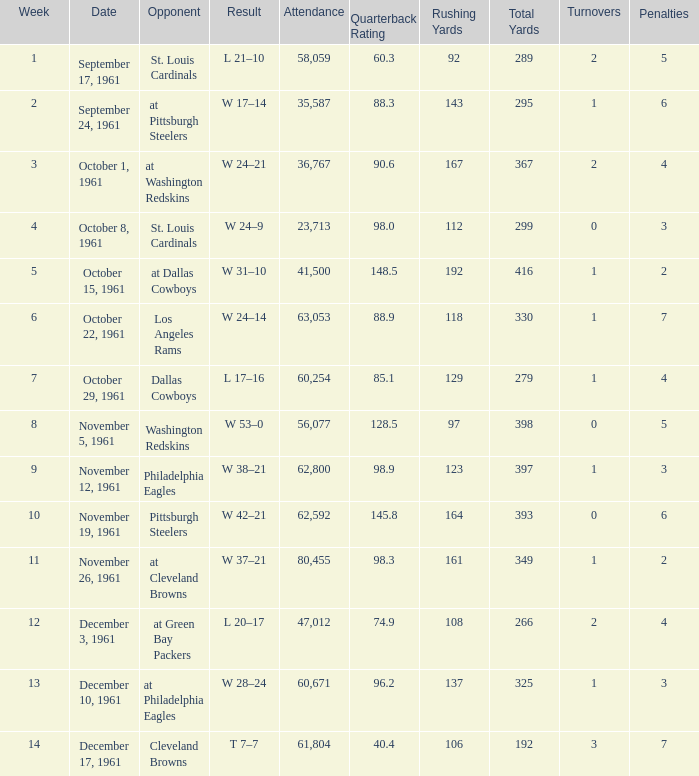Can you give me this table as a dict? {'header': ['Week', 'Date', 'Opponent', 'Result', 'Attendance', 'Quarterback Rating', 'Rushing Yards', 'Total Yards', 'Turnovers', 'Penalties '], 'rows': [['1', 'September 17, 1961', 'St. Louis Cardinals', 'L 21–10', '58,059', '60.3', '92', '289', '2', '5'], ['2', 'September 24, 1961', 'at Pittsburgh Steelers', 'W 17–14', '35,587', '88.3', '143', '295', '1', '6'], ['3', 'October 1, 1961', 'at Washington Redskins', 'W 24–21', '36,767', '90.6', '167', '367', '2', '4'], ['4', 'October 8, 1961', 'St. Louis Cardinals', 'W 24–9', '23,713', '98.0', '112', '299', '0', '3'], ['5', 'October 15, 1961', 'at Dallas Cowboys', 'W 31–10', '41,500', '148.5', '192', '416', '1', '2'], ['6', 'October 22, 1961', 'Los Angeles Rams', 'W 24–14', '63,053', '88.9', '118', '330', '1', '7'], ['7', 'October 29, 1961', 'Dallas Cowboys', 'L 17–16', '60,254', '85.1', '129', '279', '1', '4'], ['8', 'November 5, 1961', 'Washington Redskins', 'W 53–0', '56,077', '128.5', '97', '398', '0', '5'], ['9', 'November 12, 1961', 'Philadelphia Eagles', 'W 38–21', '62,800', '98.9', '123', '397', '1', '3'], ['10', 'November 19, 1961', 'Pittsburgh Steelers', 'W 42–21', '62,592', '145.8', '164', '393', '0', '6'], ['11', 'November 26, 1961', 'at Cleveland Browns', 'W 37–21', '80,455', '98.3', '161', '349', '1', '2'], ['12', 'December 3, 1961', 'at Green Bay Packers', 'L 20–17', '47,012', '74.9', '108', '266', '2', '4'], ['13', 'December 10, 1961', 'at Philadelphia Eagles', 'W 28–24', '60,671', '96.2', '137', '325', '1', '3'], ['14', 'December 17, 1961', 'Cleveland Browns', 'T 7–7', '61,804', '40.4', '106', '192', '3', '7']]} What was the result on october 8, 1961? W 24–9. 